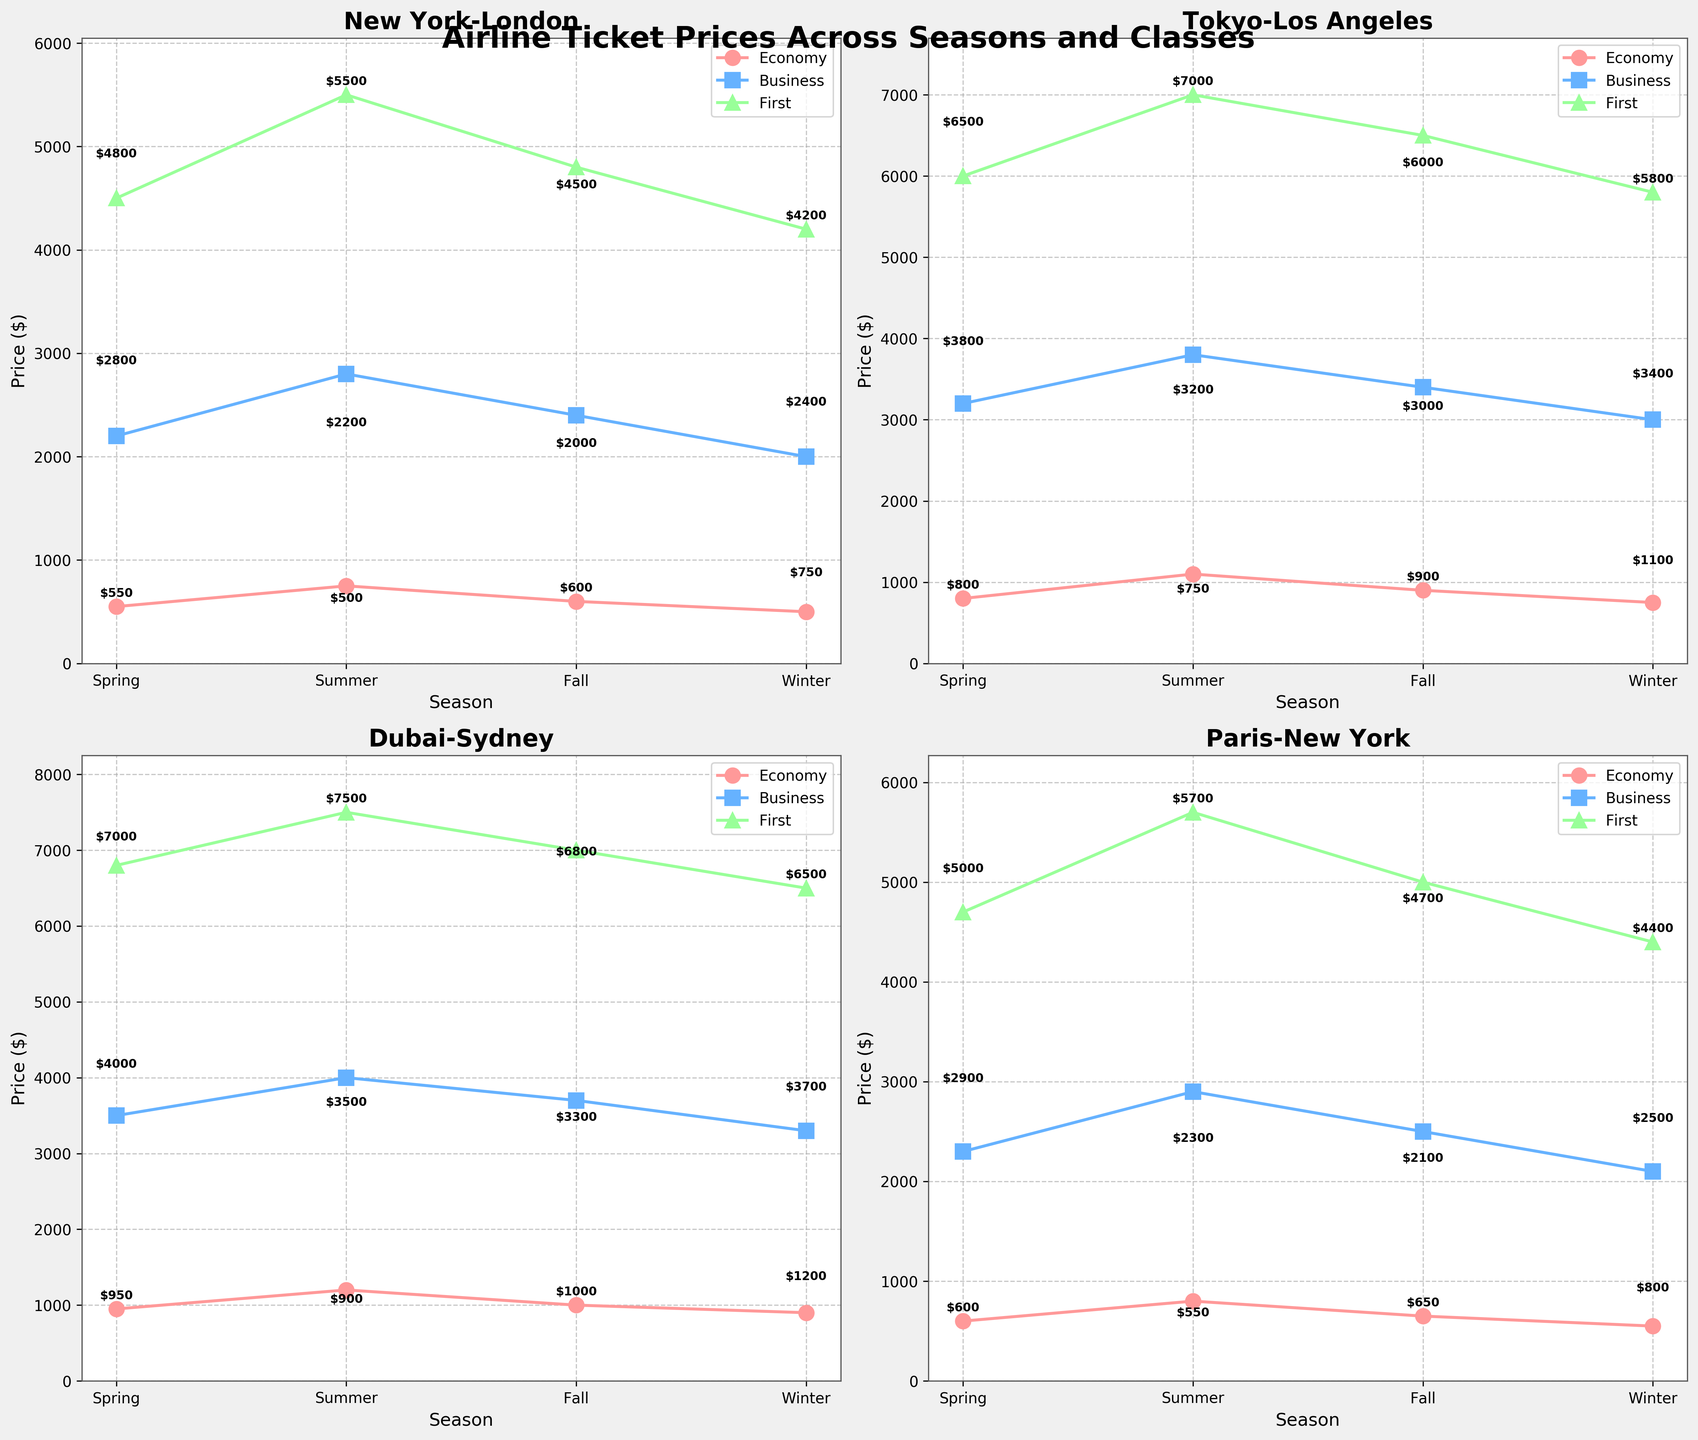What is the title of the figure? The title of the figure is displayed prominently at the top. It reads "Airline Ticket Prices Across Seasons and Classes," which provides an overview of the data being displayed.
Answer: Airline Ticket Prices Across Seasons and Classes Which route has the highest first-class ticket price in summer? To find the highest first-class ticket price for summer, look at the summer data points across all routes. The highest first-class ticket price is $7500 for the Dubai-Sydney route.
Answer: Dubai-Sydney How do the economy class prices between New York-London and Paris-New York in winter compare? To compare the economy prices, find the winter prices for each route. New York-London in winter has an economy price of $500, while Paris-New York has an economy price of $550. Therefore, Paris-New York is $50 more expensive than New York-London.
Answer: Paris-New York is $50 more expensive What is the average economy class price for the Tokyo-Los Angeles route across all seasons? To find the average, sum the economy class prices for Tokyo-Los Angeles ($800, $1100, $900, $750) and divide by the number of seasons (4). The total is $3550, so the average is $3550/4 = $887.50.
Answer: $887.50 Which season experiences the highest variance in business class ticket prices for the given routes? To determine the highest variance, examine the business class prices for each season across all routes. Summer has the highest variance with prices: 2800 (New York-London), 3800 (Tokyo-Los Angeles), 4000 (Dubai-Sydney), 2900 (Paris-New York). Calculating variance between these values shows that summer has the most fluctuation.
Answer: Summer In which season is the first-class ticket price for the New York-London route the lowest? Examine the first-class prices for New York-London for each season: Spring ($4500), Summer ($5500), Fall ($4800), Winter ($4200). The lowest price corresponds to Winter ($4200).
Answer: Winter Is there any route where the ticket prices for all classes increase from winter to summer? Check all routes for a price increase in every class between winter and summer. Paris-New York has prices increasing in all classes from winter (Economy $550, Business $2100, First $4400) to summer (Economy $800, Business $2900, First $5700).
Answer: Paris-New York How much more does a first-class ticket cost compared to a business class ticket on average for Dubai-Sydney across all seasons? Calculate the average first-class and business class prices for Dubai-Sydney. First-class averages to ($6800 + $7500 + $7000 + $6500) / 4 = $6950. Business class averages to ($3500 + $4000 + $3700 + $3300) / 4 = $3625. The difference is $6950 - $3625 = $3325.
Answer: $3325 What is the trend in business class prices for Tokyo-Los Angeles from spring to winter? Look at the business class prices: Spring ($3200), Summer ($3800), Fall ($3400), Winter ($3000). The prices peak in Summer and then decrease towards Winter.
Answer: Peaks in Summer, decreases towards Winter How much does the first-class ticket price for Paris-New York increase from spring to summer? Look at the first-class prices for Paris-New York: Spring ($4700) and Summer ($5700). The increase is $5700 - $4700 = $1000.
Answer: $1000 